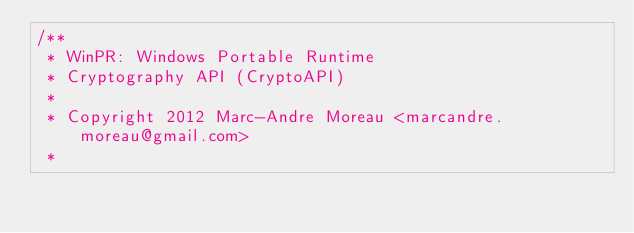Convert code to text. <code><loc_0><loc_0><loc_500><loc_500><_C_>/**
 * WinPR: Windows Portable Runtime
 * Cryptography API (CryptoAPI)
 *
 * Copyright 2012 Marc-Andre Moreau <marcandre.moreau@gmail.com>
 *</code> 